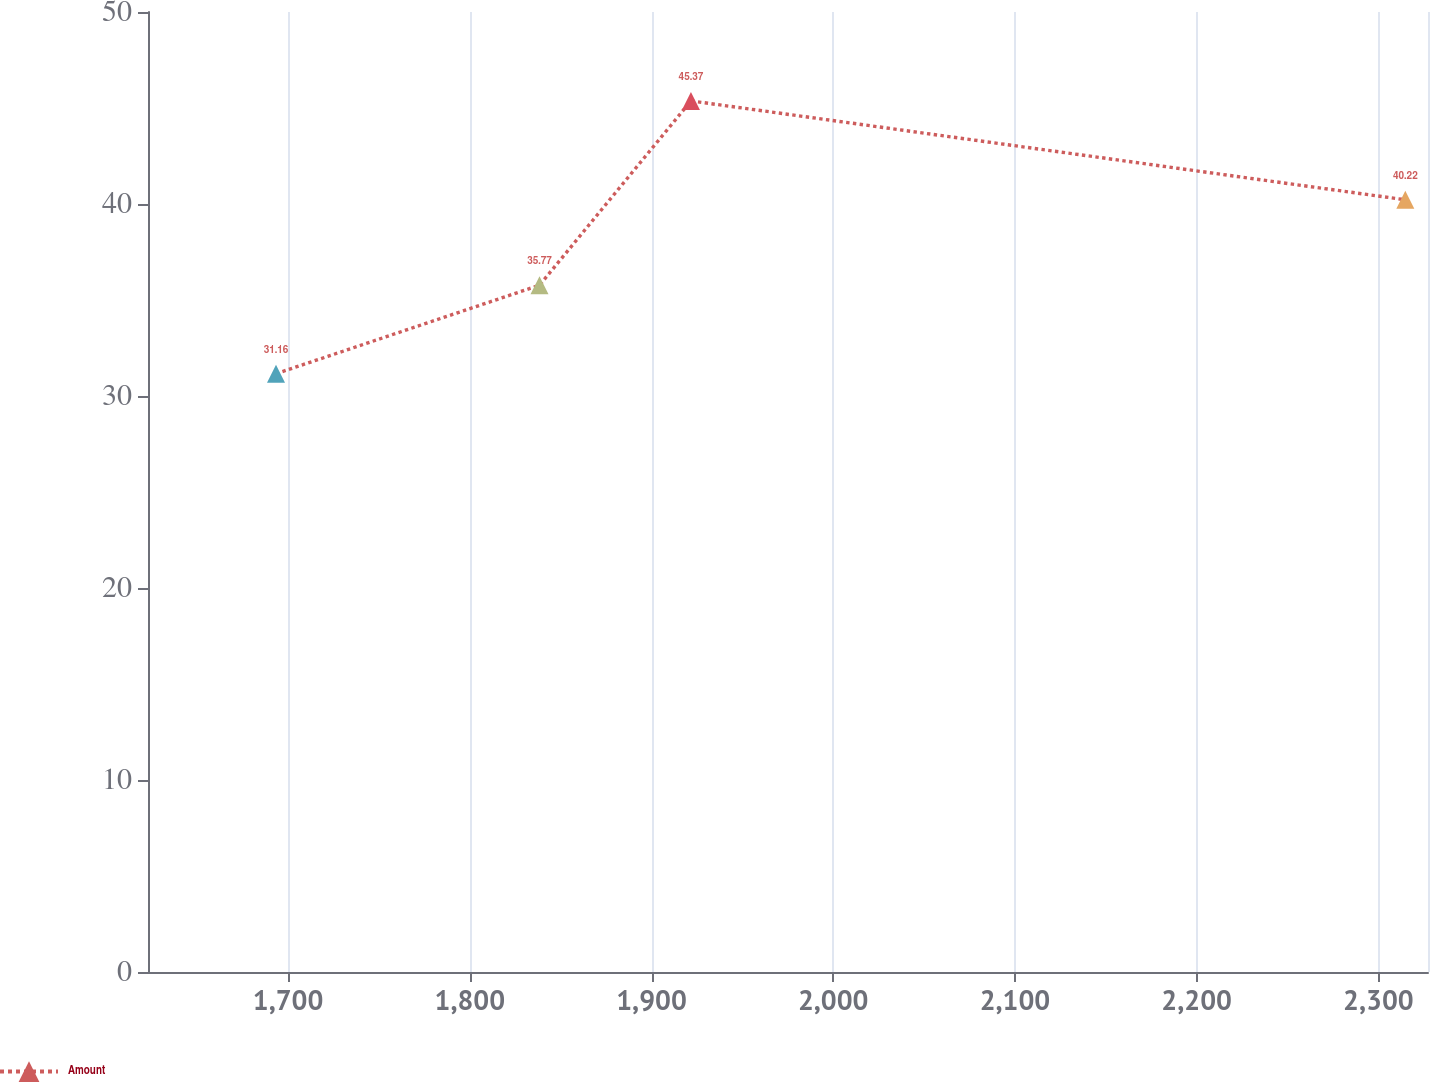<chart> <loc_0><loc_0><loc_500><loc_500><line_chart><ecel><fcel>Amount<nl><fcel>1693.35<fcel>31.16<nl><fcel>1838.36<fcel>35.77<nl><fcel>1921.71<fcel>45.37<nl><fcel>2314.84<fcel>40.22<nl><fcel>2397.76<fcel>37.19<nl></chart> 